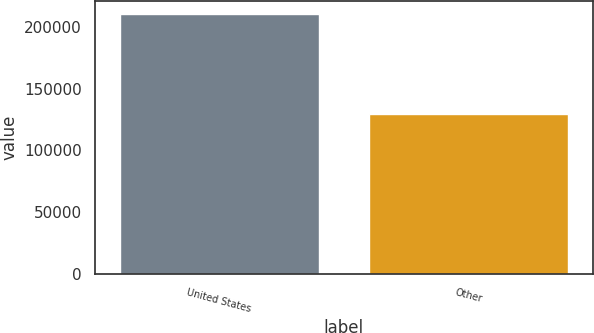<chart> <loc_0><loc_0><loc_500><loc_500><bar_chart><fcel>United States<fcel>Other<nl><fcel>210559<fcel>129209<nl></chart> 